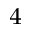<formula> <loc_0><loc_0><loc_500><loc_500>^ { 4 }</formula> 